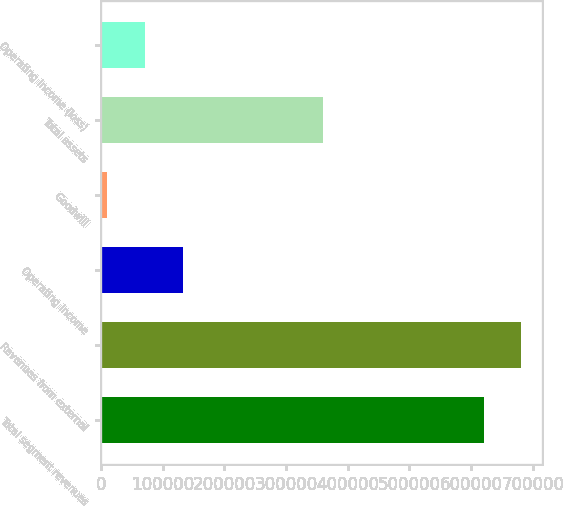Convert chart. <chart><loc_0><loc_0><loc_500><loc_500><bar_chart><fcel>Total segment revenues<fcel>Revenues from external<fcel>Operating income<fcel>Goodwill<fcel>Total assets<fcel>Operating income (loss)<nl><fcel>620183<fcel>681170<fcel>132289<fcel>10316<fcel>359957<fcel>71302.7<nl></chart> 